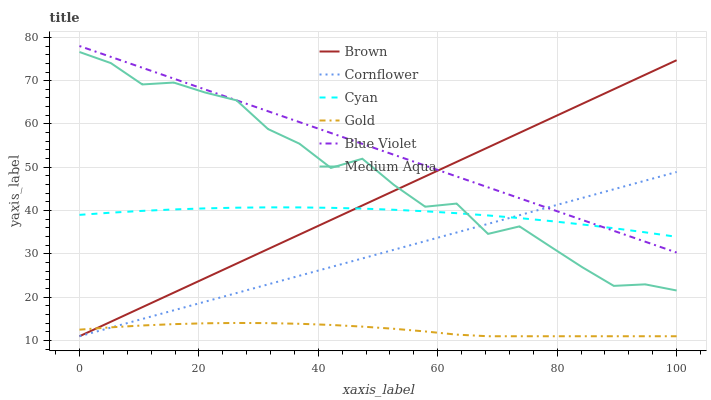Does Gold have the minimum area under the curve?
Answer yes or no. Yes. Does Blue Violet have the maximum area under the curve?
Answer yes or no. Yes. Does Cornflower have the minimum area under the curve?
Answer yes or no. No. Does Cornflower have the maximum area under the curve?
Answer yes or no. No. Is Cornflower the smoothest?
Answer yes or no. Yes. Is Medium Aqua the roughest?
Answer yes or no. Yes. Is Gold the smoothest?
Answer yes or no. No. Is Gold the roughest?
Answer yes or no. No. Does Brown have the lowest value?
Answer yes or no. Yes. Does Medium Aqua have the lowest value?
Answer yes or no. No. Does Blue Violet have the highest value?
Answer yes or no. Yes. Does Cornflower have the highest value?
Answer yes or no. No. Is Gold less than Medium Aqua?
Answer yes or no. Yes. Is Medium Aqua greater than Gold?
Answer yes or no. Yes. Does Cyan intersect Cornflower?
Answer yes or no. Yes. Is Cyan less than Cornflower?
Answer yes or no. No. Is Cyan greater than Cornflower?
Answer yes or no. No. Does Gold intersect Medium Aqua?
Answer yes or no. No. 